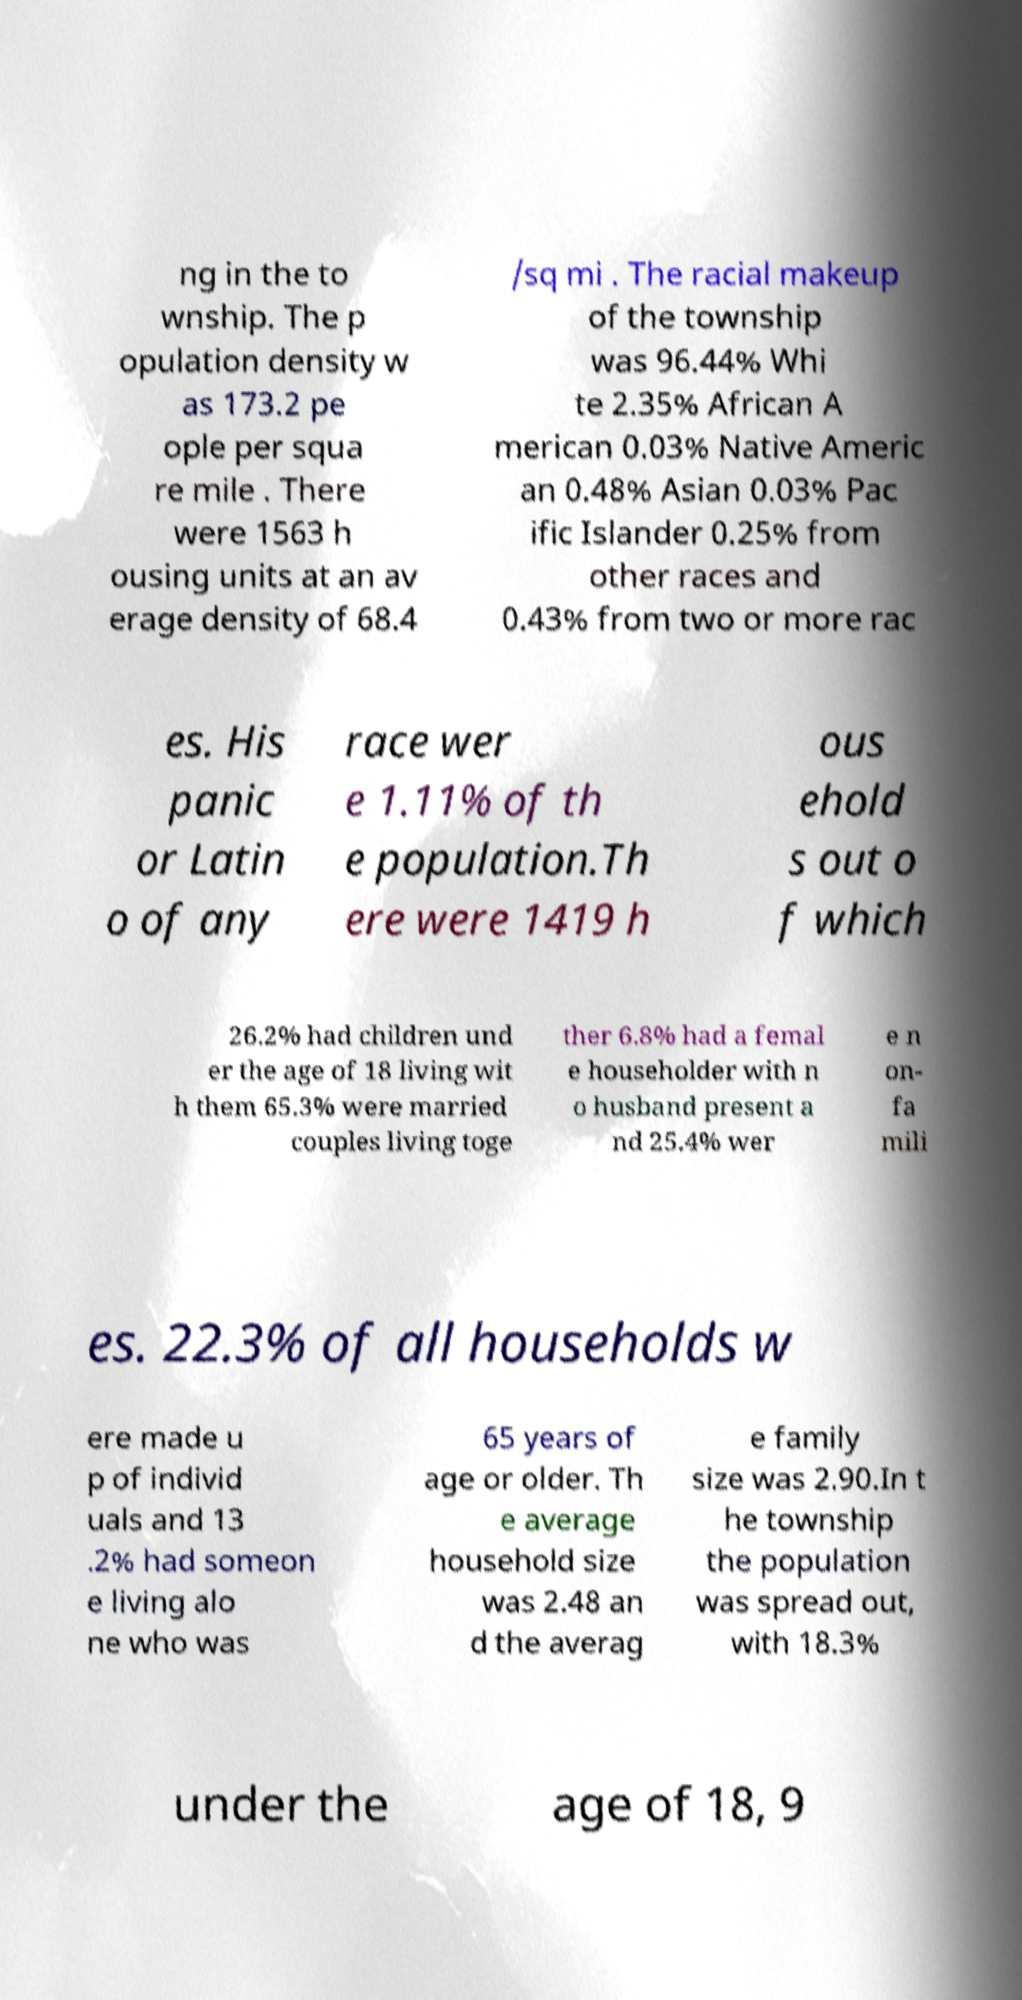Could you extract and type out the text from this image? ng in the to wnship. The p opulation density w as 173.2 pe ople per squa re mile . There were 1563 h ousing units at an av erage density of 68.4 /sq mi . The racial makeup of the township was 96.44% Whi te 2.35% African A merican 0.03% Native Americ an 0.48% Asian 0.03% Pac ific Islander 0.25% from other races and 0.43% from two or more rac es. His panic or Latin o of any race wer e 1.11% of th e population.Th ere were 1419 h ous ehold s out o f which 26.2% had children und er the age of 18 living wit h them 65.3% were married couples living toge ther 6.8% had a femal e householder with n o husband present a nd 25.4% wer e n on- fa mili es. 22.3% of all households w ere made u p of individ uals and 13 .2% had someon e living alo ne who was 65 years of age or older. Th e average household size was 2.48 an d the averag e family size was 2.90.In t he township the population was spread out, with 18.3% under the age of 18, 9 